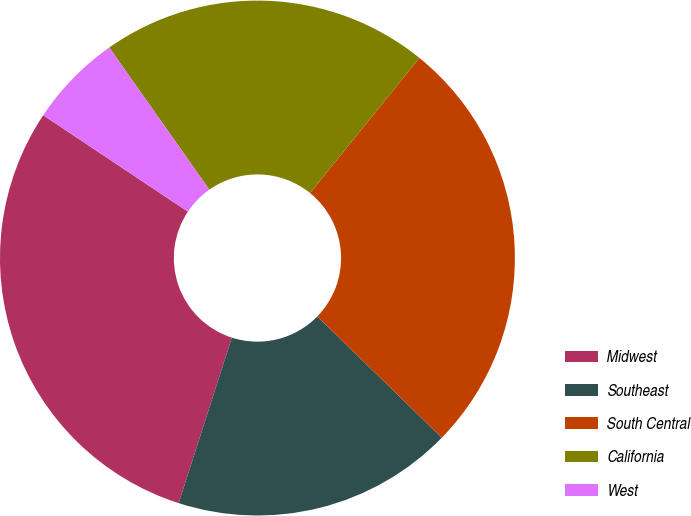Convert chart to OTSL. <chart><loc_0><loc_0><loc_500><loc_500><pie_chart><fcel>Midwest<fcel>Southeast<fcel>South Central<fcel>California<fcel>West<nl><fcel>29.41%<fcel>17.65%<fcel>26.47%<fcel>20.59%<fcel>5.88%<nl></chart> 